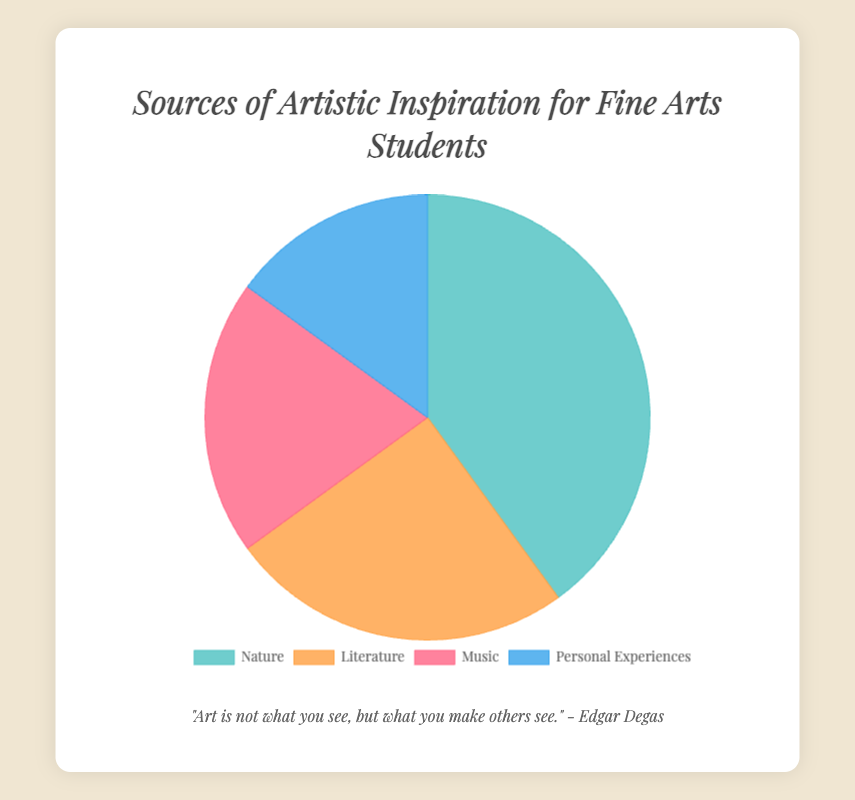What percentage of Fine Arts students draw inspiration from nature? The pie chart shows that the "Nature" section constitutes 40% of the data.
Answer: 40% Which source of inspiration has the smallest percentage? According to the pie chart, "Personal Experiences" represents the smallest segment with 15%.
Answer: Personal Experiences How much greater is the percentage of students inspired by Nature compared to those inspired by Personal Experiences? Subtract the percentage of Personal Experiences (15%) from Nature (40%). 40% - 15% = 25%.
Answer: 25% If you combine the percentages of Literature and Music, how does it compare to the percentage of Nature? Sum the percentages of Literature (25%) and Music (20%), which equals 45%. Nature is 40%, so 45% is greater than 40%.
Answer: 45% is greater What is the ratio of students inspired by Nature to those inspired by Music? Divide the percentage of Nature (40%) by the percentage of Music (20%). 40% / 20% = 2.
Answer: 2:1 Which sources have a combined percentage that is more than half of the total inspiration sources? Combine the percentages of sources to see which surpass 50%. Nature (40%) + Literature (25%) = 65%; Nature (40%) + Music (20%) = 60%; Nature (40%) + Personal Experiences (15%) = 55%. All these combinations surpass 50%.
Answer: Nature + Literature, Nature + Music, Nature + Personal Experiences Among all the sources, which one has the second-largest percentage? Observing the pie chart, "Literature" is the second-largest slice with 25%.
Answer: Literature By what percentage does Literature exceed Music as a source of inspiration? Subtract the percentage of Music (20%) from Literature (25%). 25% - 20% = 5%.
Answer: 5% What do the colors represent in the pie chart? The colors differentiate between the four sources of artistic inspiration: Nature (greenish), Literature (orangish), Music (pinkish), and Personal Experiences (blueish).
Answer: Different sources of inspiration If the data were to be displayed in descending order of percentage, which source would appear last? Ordering the percentages from highest to lowest: Nature (40%), Literature (25%), Music (20%), and Personal Experiences (15%). Thus, Personal Experiences would appear last.
Answer: Personal Experiences 